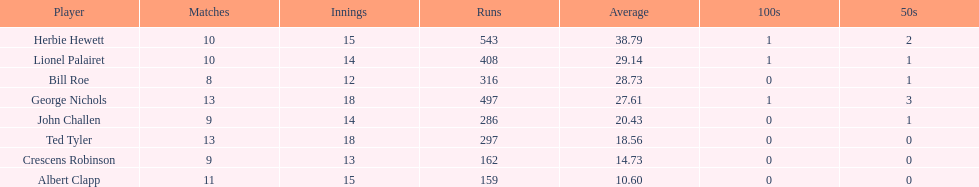By how many runs does john exceed albert? 127. 